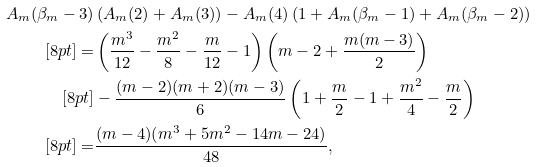<formula> <loc_0><loc_0><loc_500><loc_500>A _ { m } ( \beta _ { m } - 3 ) & \left ( A _ { m } ( 2 ) + A _ { m } ( 3 ) \right ) - A _ { m } ( 4 ) \left ( 1 + A _ { m } ( \beta _ { m } - 1 ) + A _ { m } ( \beta _ { m } - 2 ) \right ) \\ [ 8 p t ] = & \left ( \frac { m ^ { 3 } } { 1 2 } - \frac { m ^ { 2 } } { 8 } - \frac { m } { 1 2 } - 1 \right ) \left ( m - 2 + \frac { m ( m - 3 ) } { 2 } \right ) \\ [ 8 p t ] & - \frac { ( m - 2 ) ( m + 2 ) ( m - 3 ) } { 6 } \left ( 1 + \frac { m } { 2 } - 1 + \frac { m ^ { 2 } } { 4 } - \frac { m } { 2 } \right ) \\ [ 8 p t ] = & \frac { ( m - 4 ) ( m ^ { 3 } + 5 m ^ { 2 } - 1 4 m - 2 4 ) } { 4 8 } ,</formula> 